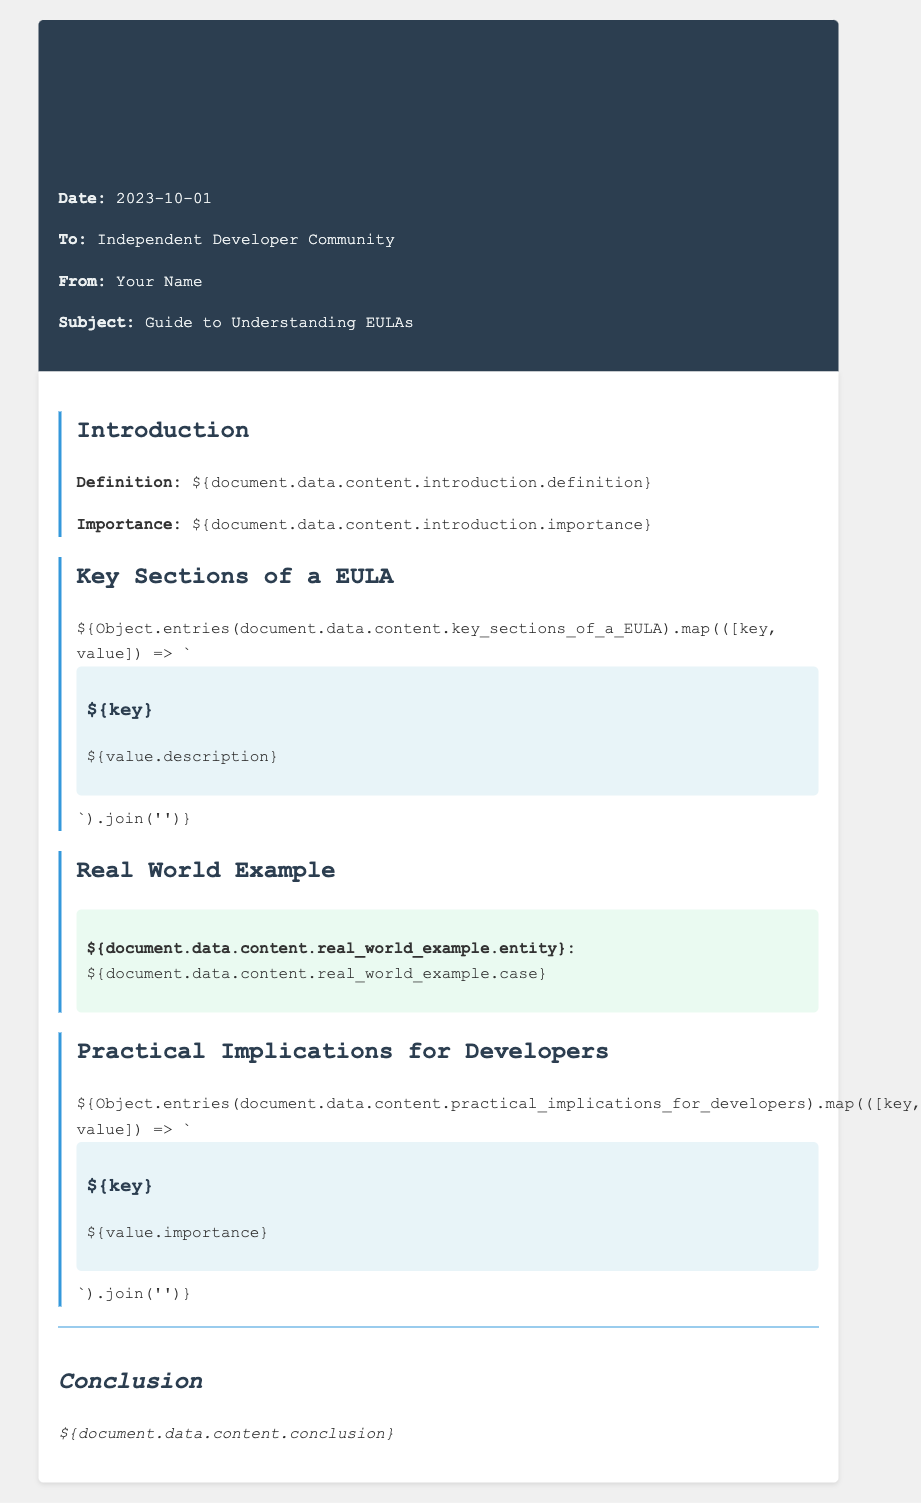What is the date of the memo? The date is stated at the beginning of the memo, which is 2023-10-01.
Answer: 2023-10-01 Who is the memo addressed to? The recipient of the memo is mentioned in the header, specifically "Independent Developer Community."
Answer: Independent Developer Community What is the definition of EULA provided in the memo? The definition of EULA is found in the introduction section.
Answer: Definition What is one key section of a EULA mentioned? The key sections of a EULA are listed in a specific section, each with its own title.
Answer: Title What is the real-world example entity? The real-world example is described with an entity and a corresponding case in a designated section of the memo.
Answer: Entity What is one practical implication for developers? Practical implications for developers are outlined in a specific section, each stating its importance.
Answer: Importance What is the main subject of the memo? The subject is explicitly mentioned in the header of the memo.
Answer: Guide to Understanding EULAs What is the conclusion summarized as? The conclusion is provided in its own section and summarizes the memo's content.
Answer: Conclusion What styling is used for the memo header? The memo header styling is described through the use of colors and background.
Answer: Background color 